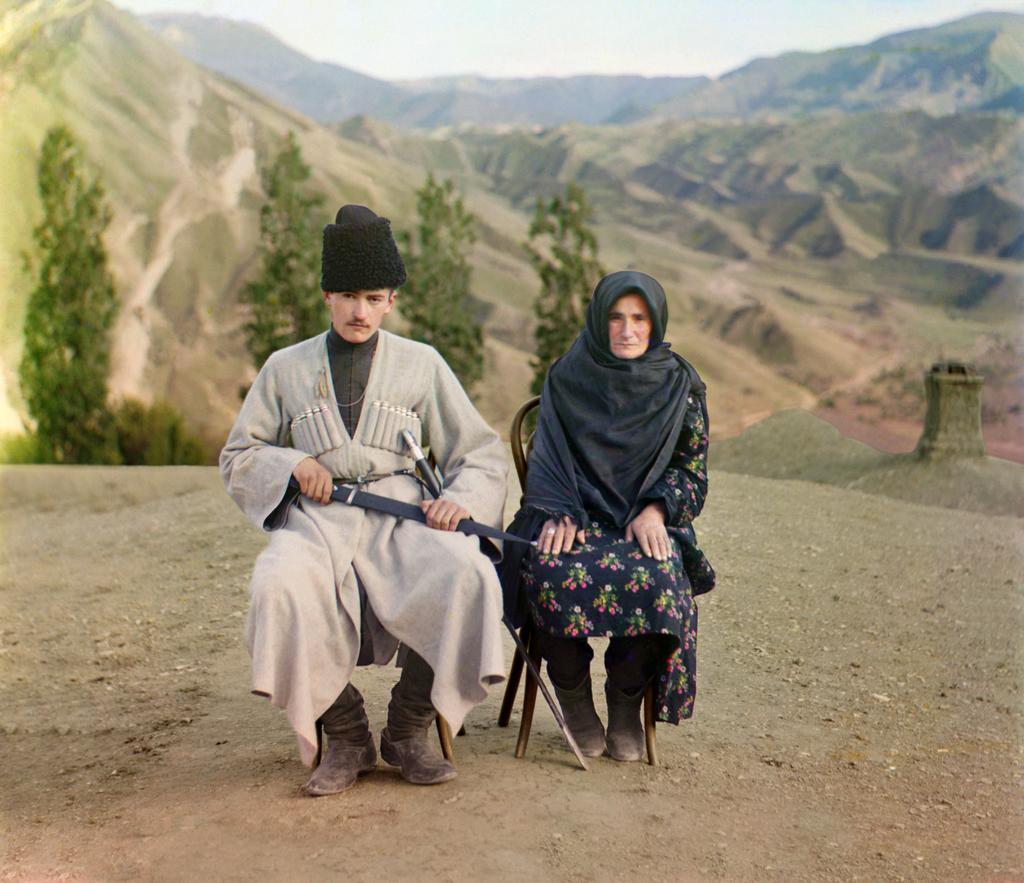Please provide a concise description of this image. In this image, we can see a woman and man are sitting on the chairs. Here a man is holding a weapon. At the bottom, there is a ground. Background we can see hills, trees and sky. 